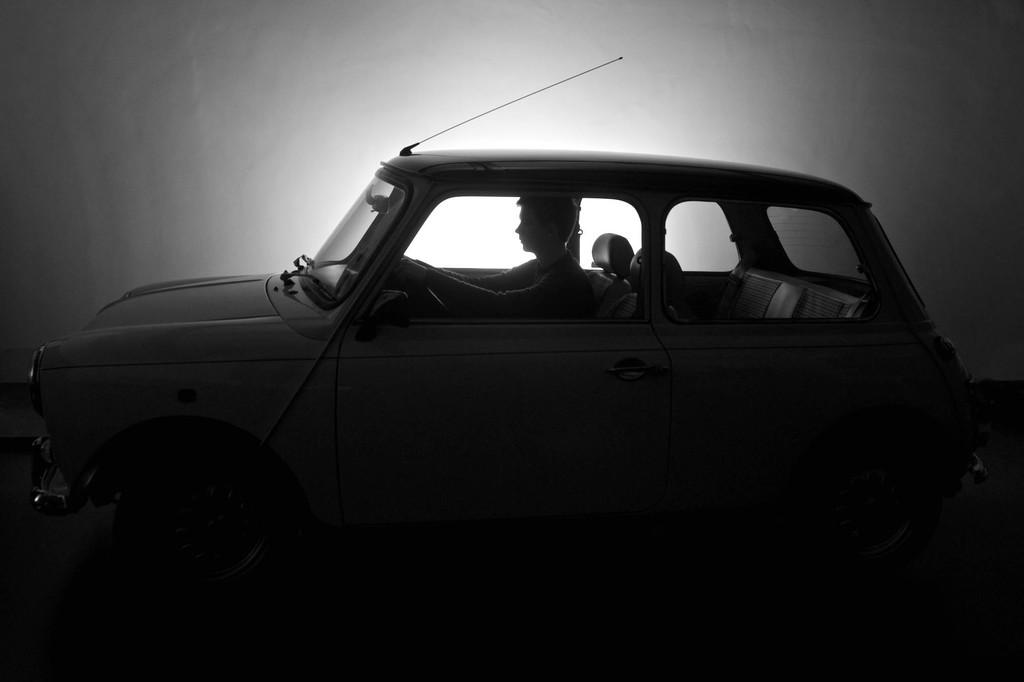What is the person in the image doing? The person is sitting inside a vehicle. What can be seen in the background of the image? There is a wall visible in the background of the image. How would you describe the lighting in the image? The bottom of the image appears to be dark. What type of bulb is being used to illuminate the basket in the image? There is no bulb or basket present in the image. 